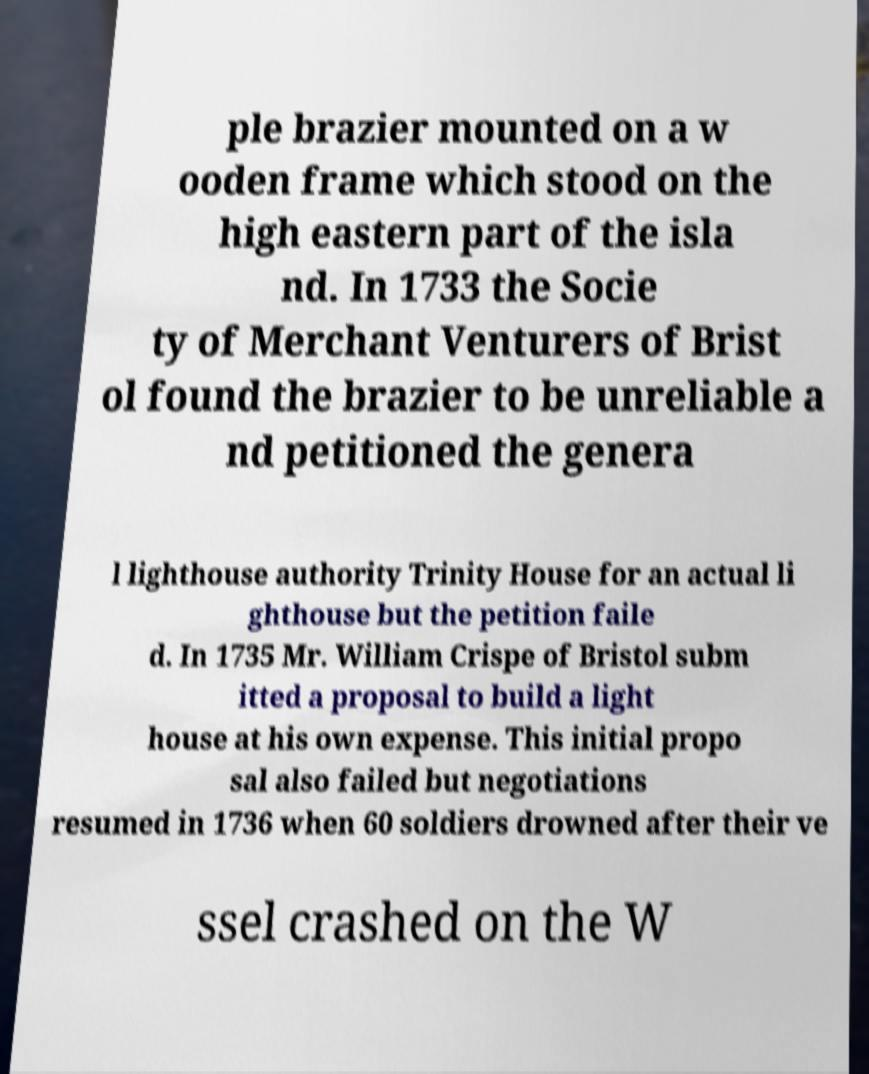Could you assist in decoding the text presented in this image and type it out clearly? ple brazier mounted on a w ooden frame which stood on the high eastern part of the isla nd. In 1733 the Socie ty of Merchant Venturers of Brist ol found the brazier to be unreliable a nd petitioned the genera l lighthouse authority Trinity House for an actual li ghthouse but the petition faile d. In 1735 Mr. William Crispe of Bristol subm itted a proposal to build a light house at his own expense. This initial propo sal also failed but negotiations resumed in 1736 when 60 soldiers drowned after their ve ssel crashed on the W 